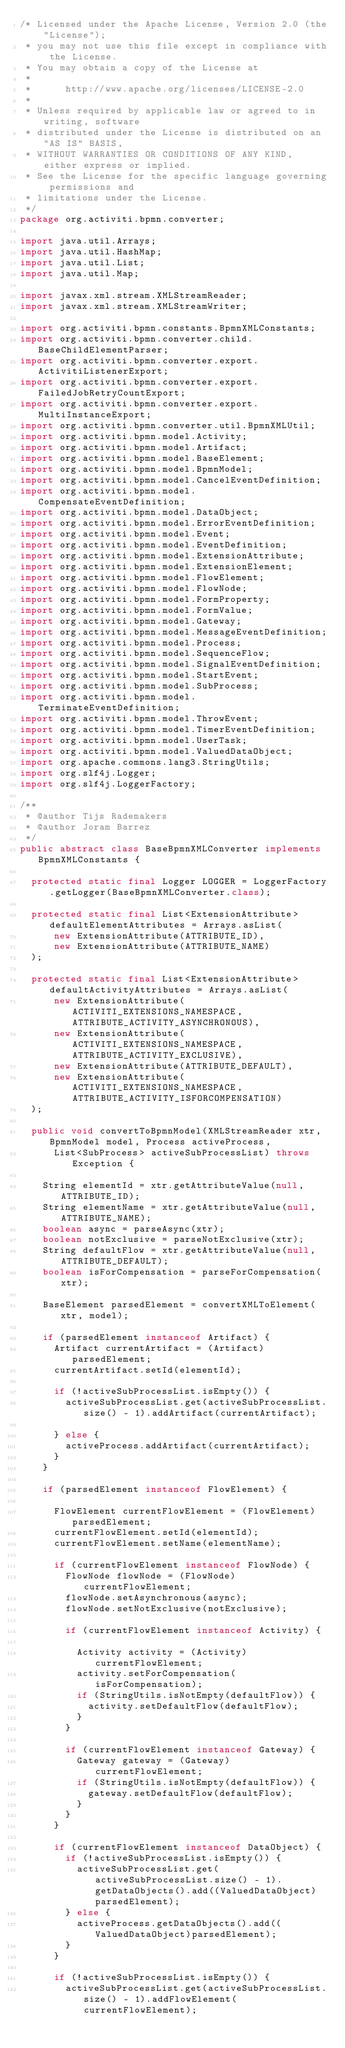Convert code to text. <code><loc_0><loc_0><loc_500><loc_500><_Java_>/* Licensed under the Apache License, Version 2.0 (the "License");
 * you may not use this file except in compliance with the License.
 * You may obtain a copy of the License at
 * 
 *      http://www.apache.org/licenses/LICENSE-2.0
 * 
 * Unless required by applicable law or agreed to in writing, software
 * distributed under the License is distributed on an "AS IS" BASIS,
 * WITHOUT WARRANTIES OR CONDITIONS OF ANY KIND, either express or implied.
 * See the License for the specific language governing permissions and
 * limitations under the License.
 */
package org.activiti.bpmn.converter;

import java.util.Arrays;
import java.util.HashMap;
import java.util.List;
import java.util.Map;

import javax.xml.stream.XMLStreamReader;
import javax.xml.stream.XMLStreamWriter;

import org.activiti.bpmn.constants.BpmnXMLConstants;
import org.activiti.bpmn.converter.child.BaseChildElementParser;
import org.activiti.bpmn.converter.export.ActivitiListenerExport;
import org.activiti.bpmn.converter.export.FailedJobRetryCountExport;
import org.activiti.bpmn.converter.export.MultiInstanceExport;
import org.activiti.bpmn.converter.util.BpmnXMLUtil;
import org.activiti.bpmn.model.Activity;
import org.activiti.bpmn.model.Artifact;
import org.activiti.bpmn.model.BaseElement;
import org.activiti.bpmn.model.BpmnModel;
import org.activiti.bpmn.model.CancelEventDefinition;
import org.activiti.bpmn.model.CompensateEventDefinition;
import org.activiti.bpmn.model.DataObject;
import org.activiti.bpmn.model.ErrorEventDefinition;
import org.activiti.bpmn.model.Event;
import org.activiti.bpmn.model.EventDefinition;
import org.activiti.bpmn.model.ExtensionAttribute;
import org.activiti.bpmn.model.ExtensionElement;
import org.activiti.bpmn.model.FlowElement;
import org.activiti.bpmn.model.FlowNode;
import org.activiti.bpmn.model.FormProperty;
import org.activiti.bpmn.model.FormValue;
import org.activiti.bpmn.model.Gateway;
import org.activiti.bpmn.model.MessageEventDefinition;
import org.activiti.bpmn.model.Process;
import org.activiti.bpmn.model.SequenceFlow;
import org.activiti.bpmn.model.SignalEventDefinition;
import org.activiti.bpmn.model.StartEvent;
import org.activiti.bpmn.model.SubProcess;
import org.activiti.bpmn.model.TerminateEventDefinition;
import org.activiti.bpmn.model.ThrowEvent;
import org.activiti.bpmn.model.TimerEventDefinition;
import org.activiti.bpmn.model.UserTask;
import org.activiti.bpmn.model.ValuedDataObject;
import org.apache.commons.lang3.StringUtils;
import org.slf4j.Logger;
import org.slf4j.LoggerFactory;

/**
 * @author Tijs Rademakers
 * @author Joram Barrez
 */
public abstract class BaseBpmnXMLConverter implements BpmnXMLConstants {

  protected static final Logger LOGGER = LoggerFactory.getLogger(BaseBpmnXMLConverter.class);
  
  protected static final List<ExtensionAttribute> defaultElementAttributes = Arrays.asList(
      new ExtensionAttribute(ATTRIBUTE_ID),
      new ExtensionAttribute(ATTRIBUTE_NAME)
  );
  
  protected static final List<ExtensionAttribute> defaultActivityAttributes = Arrays.asList(
      new ExtensionAttribute(ACTIVITI_EXTENSIONS_NAMESPACE, ATTRIBUTE_ACTIVITY_ASYNCHRONOUS), 
      new ExtensionAttribute(ACTIVITI_EXTENSIONS_NAMESPACE, ATTRIBUTE_ACTIVITY_EXCLUSIVE), 
      new ExtensionAttribute(ATTRIBUTE_DEFAULT), 
      new ExtensionAttribute(ACTIVITI_EXTENSIONS_NAMESPACE, ATTRIBUTE_ACTIVITY_ISFORCOMPENSATION)
  );
  
  public void convertToBpmnModel(XMLStreamReader xtr, BpmnModel model, Process activeProcess, 
      List<SubProcess> activeSubProcessList) throws Exception {
    
    String elementId = xtr.getAttributeValue(null, ATTRIBUTE_ID);
    String elementName = xtr.getAttributeValue(null, ATTRIBUTE_NAME);
    boolean async = parseAsync(xtr);
    boolean notExclusive = parseNotExclusive(xtr);
    String defaultFlow = xtr.getAttributeValue(null, ATTRIBUTE_DEFAULT);
    boolean isForCompensation = parseForCompensation(xtr);
    
    BaseElement parsedElement = convertXMLToElement(xtr, model);
    
    if (parsedElement instanceof Artifact) {
      Artifact currentArtifact = (Artifact) parsedElement;
      currentArtifact.setId(elementId);

      if (!activeSubProcessList.isEmpty()) {
        activeSubProcessList.get(activeSubProcessList.size() - 1).addArtifact(currentArtifact);

      } else {
        activeProcess.addArtifact(currentArtifact);
      }
    }
    
    if (parsedElement instanceof FlowElement) {
      
      FlowElement currentFlowElement = (FlowElement) parsedElement;
      currentFlowElement.setId(elementId);
      currentFlowElement.setName(elementName);
      
      if (currentFlowElement instanceof FlowNode) {
        FlowNode flowNode = (FlowNode) currentFlowElement;
        flowNode.setAsynchronous(async);
        flowNode.setNotExclusive(notExclusive);
        
        if (currentFlowElement instanceof Activity) {
          
          Activity activity = (Activity) currentFlowElement;
          activity.setForCompensation(isForCompensation);
          if (StringUtils.isNotEmpty(defaultFlow)) {
            activity.setDefaultFlow(defaultFlow);
          }
        }
        
        if (currentFlowElement instanceof Gateway) {
          Gateway gateway = (Gateway) currentFlowElement;
          if (StringUtils.isNotEmpty(defaultFlow)) {
            gateway.setDefaultFlow(defaultFlow);
          }
        }
      }
      
      if (currentFlowElement instanceof DataObject) {
        if (!activeSubProcessList.isEmpty()) {
          activeSubProcessList.get(activeSubProcessList.size() - 1).getDataObjects().add((ValuedDataObject)parsedElement);
        } else {
          activeProcess.getDataObjects().add((ValuedDataObject)parsedElement);
        }
      }

      if (!activeSubProcessList.isEmpty()) {
        activeSubProcessList.get(activeSubProcessList.size() - 1).addFlowElement(currentFlowElement);</code> 